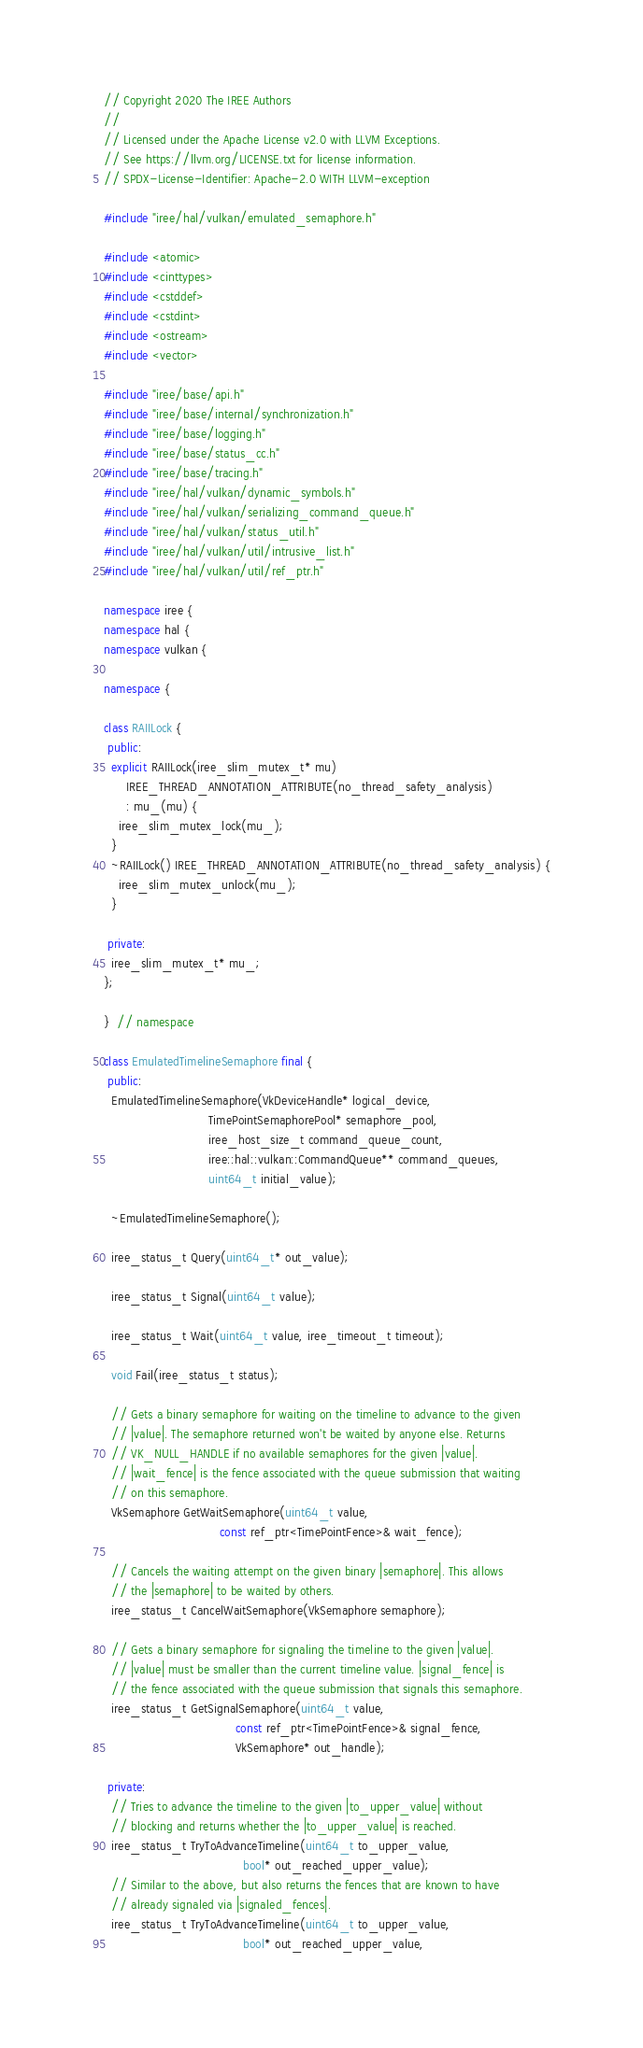<code> <loc_0><loc_0><loc_500><loc_500><_C++_>// Copyright 2020 The IREE Authors
//
// Licensed under the Apache License v2.0 with LLVM Exceptions.
// See https://llvm.org/LICENSE.txt for license information.
// SPDX-License-Identifier: Apache-2.0 WITH LLVM-exception

#include "iree/hal/vulkan/emulated_semaphore.h"

#include <atomic>
#include <cinttypes>
#include <cstddef>
#include <cstdint>
#include <ostream>
#include <vector>

#include "iree/base/api.h"
#include "iree/base/internal/synchronization.h"
#include "iree/base/logging.h"
#include "iree/base/status_cc.h"
#include "iree/base/tracing.h"
#include "iree/hal/vulkan/dynamic_symbols.h"
#include "iree/hal/vulkan/serializing_command_queue.h"
#include "iree/hal/vulkan/status_util.h"
#include "iree/hal/vulkan/util/intrusive_list.h"
#include "iree/hal/vulkan/util/ref_ptr.h"

namespace iree {
namespace hal {
namespace vulkan {

namespace {

class RAIILock {
 public:
  explicit RAIILock(iree_slim_mutex_t* mu)
      IREE_THREAD_ANNOTATION_ATTRIBUTE(no_thread_safety_analysis)
      : mu_(mu) {
    iree_slim_mutex_lock(mu_);
  }
  ~RAIILock() IREE_THREAD_ANNOTATION_ATTRIBUTE(no_thread_safety_analysis) {
    iree_slim_mutex_unlock(mu_);
  }

 private:
  iree_slim_mutex_t* mu_;
};

}  // namespace

class EmulatedTimelineSemaphore final {
 public:
  EmulatedTimelineSemaphore(VkDeviceHandle* logical_device,
                            TimePointSemaphorePool* semaphore_pool,
                            iree_host_size_t command_queue_count,
                            iree::hal::vulkan::CommandQueue** command_queues,
                            uint64_t initial_value);

  ~EmulatedTimelineSemaphore();

  iree_status_t Query(uint64_t* out_value);

  iree_status_t Signal(uint64_t value);

  iree_status_t Wait(uint64_t value, iree_timeout_t timeout);

  void Fail(iree_status_t status);

  // Gets a binary semaphore for waiting on the timeline to advance to the given
  // |value|. The semaphore returned won't be waited by anyone else. Returns
  // VK_NULL_HANDLE if no available semaphores for the given |value|.
  // |wait_fence| is the fence associated with the queue submission that waiting
  // on this semaphore.
  VkSemaphore GetWaitSemaphore(uint64_t value,
                               const ref_ptr<TimePointFence>& wait_fence);

  // Cancels the waiting attempt on the given binary |semaphore|. This allows
  // the |semaphore| to be waited by others.
  iree_status_t CancelWaitSemaphore(VkSemaphore semaphore);

  // Gets a binary semaphore for signaling the timeline to the given |value|.
  // |value| must be smaller than the current timeline value. |signal_fence| is
  // the fence associated with the queue submission that signals this semaphore.
  iree_status_t GetSignalSemaphore(uint64_t value,
                                   const ref_ptr<TimePointFence>& signal_fence,
                                   VkSemaphore* out_handle);

 private:
  // Tries to advance the timeline to the given |to_upper_value| without
  // blocking and returns whether the |to_upper_value| is reached.
  iree_status_t TryToAdvanceTimeline(uint64_t to_upper_value,
                                     bool* out_reached_upper_value);
  // Similar to the above, but also returns the fences that are known to have
  // already signaled via |signaled_fences|.
  iree_status_t TryToAdvanceTimeline(uint64_t to_upper_value,
                                     bool* out_reached_upper_value,</code> 